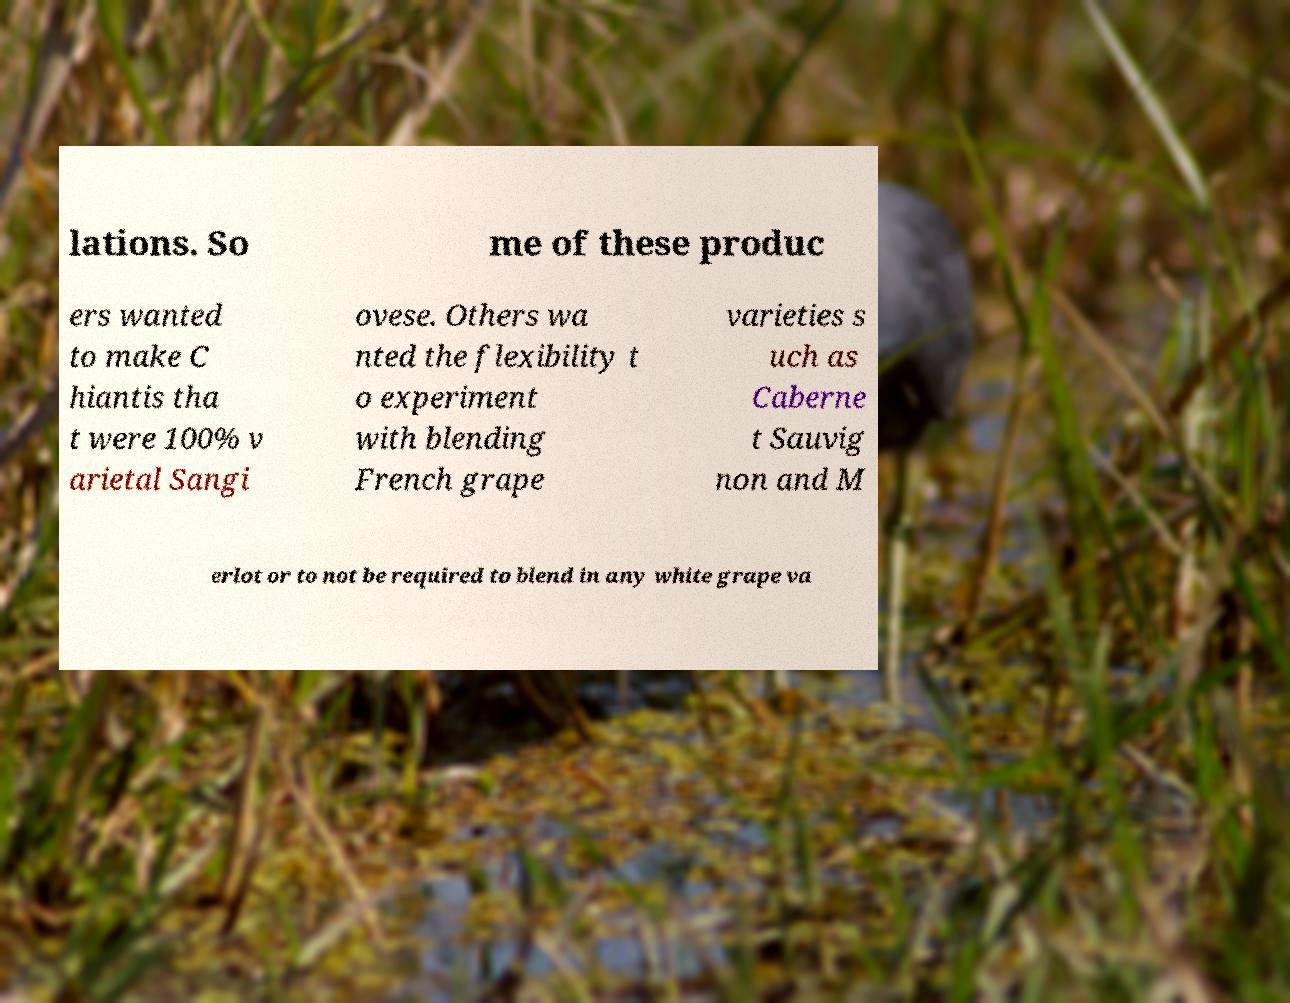There's text embedded in this image that I need extracted. Can you transcribe it verbatim? lations. So me of these produc ers wanted to make C hiantis tha t were 100% v arietal Sangi ovese. Others wa nted the flexibility t o experiment with blending French grape varieties s uch as Caberne t Sauvig non and M erlot or to not be required to blend in any white grape va 